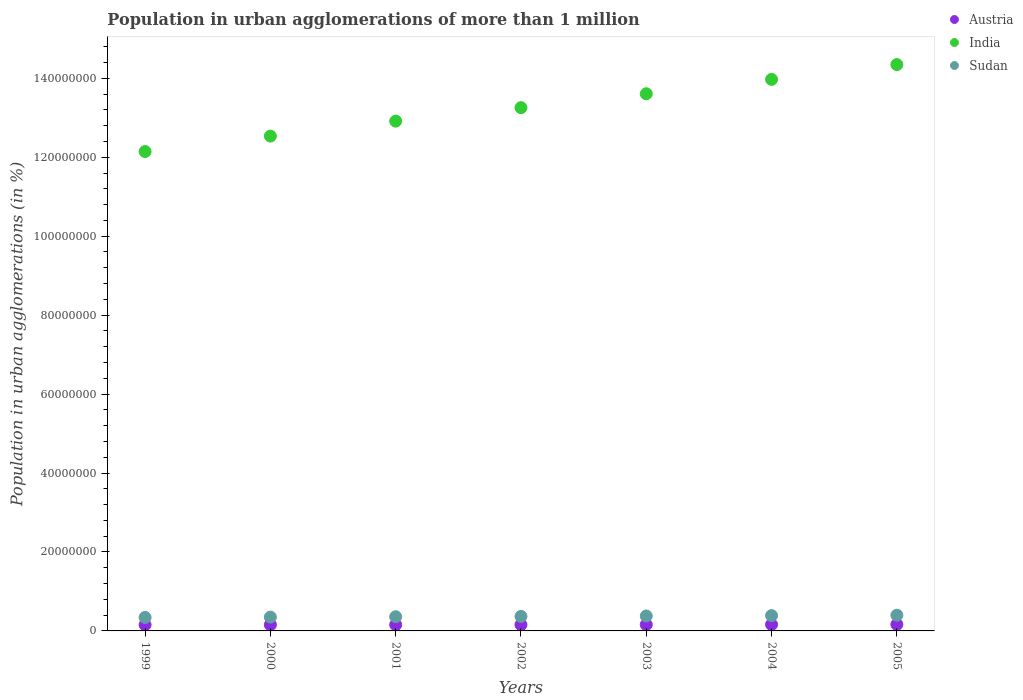Is the number of dotlines equal to the number of legend labels?
Give a very brief answer. Yes. What is the population in urban agglomerations in Sudan in 1999?
Offer a very short reply. 3.42e+06. Across all years, what is the maximum population in urban agglomerations in Austria?
Offer a very short reply. 1.64e+06. Across all years, what is the minimum population in urban agglomerations in Sudan?
Your response must be concise. 3.42e+06. In which year was the population in urban agglomerations in India minimum?
Keep it short and to the point. 1999. What is the total population in urban agglomerations in Sudan in the graph?
Keep it short and to the point. 2.58e+07. What is the difference between the population in urban agglomerations in India in 2001 and that in 2002?
Offer a very short reply. -3.41e+06. What is the difference between the population in urban agglomerations in India in 1999 and the population in urban agglomerations in Austria in 2005?
Your response must be concise. 1.20e+08. What is the average population in urban agglomerations in Sudan per year?
Your answer should be compact. 3.69e+06. In the year 1999, what is the difference between the population in urban agglomerations in India and population in urban agglomerations in Austria?
Your answer should be very brief. 1.20e+08. What is the ratio of the population in urban agglomerations in Austria in 2000 to that in 2004?
Keep it short and to the point. 0.96. Is the difference between the population in urban agglomerations in India in 2002 and 2005 greater than the difference between the population in urban agglomerations in Austria in 2002 and 2005?
Make the answer very short. No. What is the difference between the highest and the second highest population in urban agglomerations in Austria?
Offer a very short reply. 2.25e+04. What is the difference between the highest and the lowest population in urban agglomerations in Sudan?
Provide a short and direct response. 5.61e+05. In how many years, is the population in urban agglomerations in India greater than the average population in urban agglomerations in India taken over all years?
Your response must be concise. 4. Is the sum of the population in urban agglomerations in India in 1999 and 2002 greater than the maximum population in urban agglomerations in Sudan across all years?
Your answer should be compact. Yes. How many dotlines are there?
Give a very brief answer. 3. What is the difference between two consecutive major ticks on the Y-axis?
Keep it short and to the point. 2.00e+07. Does the graph contain grids?
Your answer should be compact. No. How many legend labels are there?
Make the answer very short. 3. What is the title of the graph?
Provide a short and direct response. Population in urban agglomerations of more than 1 million. Does "Euro area" appear as one of the legend labels in the graph?
Make the answer very short. No. What is the label or title of the X-axis?
Your answer should be very brief. Years. What is the label or title of the Y-axis?
Your answer should be compact. Population in urban agglomerations (in %). What is the Population in urban agglomerations (in %) in Austria in 1999?
Your answer should be very brief. 1.55e+06. What is the Population in urban agglomerations (in %) of India in 1999?
Offer a terse response. 1.21e+08. What is the Population in urban agglomerations (in %) in Sudan in 1999?
Your response must be concise. 3.42e+06. What is the Population in urban agglomerations (in %) of Austria in 2000?
Give a very brief answer. 1.55e+06. What is the Population in urban agglomerations (in %) of India in 2000?
Provide a succinct answer. 1.25e+08. What is the Population in urban agglomerations (in %) of Sudan in 2000?
Your response must be concise. 3.51e+06. What is the Population in urban agglomerations (in %) of Austria in 2001?
Make the answer very short. 1.55e+06. What is the Population in urban agglomerations (in %) of India in 2001?
Provide a succinct answer. 1.29e+08. What is the Population in urban agglomerations (in %) of Sudan in 2001?
Give a very brief answer. 3.60e+06. What is the Population in urban agglomerations (in %) in Austria in 2002?
Keep it short and to the point. 1.57e+06. What is the Population in urban agglomerations (in %) in India in 2002?
Your answer should be very brief. 1.33e+08. What is the Population in urban agglomerations (in %) in Sudan in 2002?
Offer a very short reply. 3.69e+06. What is the Population in urban agglomerations (in %) of Austria in 2003?
Your response must be concise. 1.60e+06. What is the Population in urban agglomerations (in %) in India in 2003?
Provide a short and direct response. 1.36e+08. What is the Population in urban agglomerations (in %) in Sudan in 2003?
Your response must be concise. 3.78e+06. What is the Population in urban agglomerations (in %) of Austria in 2004?
Give a very brief answer. 1.62e+06. What is the Population in urban agglomerations (in %) of India in 2004?
Make the answer very short. 1.40e+08. What is the Population in urban agglomerations (in %) of Sudan in 2004?
Your response must be concise. 3.88e+06. What is the Population in urban agglomerations (in %) in Austria in 2005?
Your answer should be very brief. 1.64e+06. What is the Population in urban agglomerations (in %) in India in 2005?
Ensure brevity in your answer.  1.43e+08. What is the Population in urban agglomerations (in %) in Sudan in 2005?
Offer a very short reply. 3.98e+06. Across all years, what is the maximum Population in urban agglomerations (in %) in Austria?
Ensure brevity in your answer.  1.64e+06. Across all years, what is the maximum Population in urban agglomerations (in %) in India?
Keep it short and to the point. 1.43e+08. Across all years, what is the maximum Population in urban agglomerations (in %) in Sudan?
Provide a succinct answer. 3.98e+06. Across all years, what is the minimum Population in urban agglomerations (in %) of Austria?
Provide a succinct answer. 1.55e+06. Across all years, what is the minimum Population in urban agglomerations (in %) in India?
Provide a succinct answer. 1.21e+08. Across all years, what is the minimum Population in urban agglomerations (in %) of Sudan?
Your response must be concise. 3.42e+06. What is the total Population in urban agglomerations (in %) of Austria in the graph?
Make the answer very short. 1.11e+07. What is the total Population in urban agglomerations (in %) of India in the graph?
Offer a very short reply. 9.28e+08. What is the total Population in urban agglomerations (in %) of Sudan in the graph?
Your response must be concise. 2.58e+07. What is the difference between the Population in urban agglomerations (in %) in Austria in 1999 and that in 2000?
Give a very brief answer. -1032. What is the difference between the Population in urban agglomerations (in %) of India in 1999 and that in 2000?
Ensure brevity in your answer.  -3.91e+06. What is the difference between the Population in urban agglomerations (in %) in Sudan in 1999 and that in 2000?
Offer a very short reply. -8.79e+04. What is the difference between the Population in urban agglomerations (in %) in Austria in 1999 and that in 2001?
Provide a short and direct response. -4685. What is the difference between the Population in urban agglomerations (in %) in India in 1999 and that in 2001?
Provide a succinct answer. -7.70e+06. What is the difference between the Population in urban agglomerations (in %) of Sudan in 1999 and that in 2001?
Offer a terse response. -1.78e+05. What is the difference between the Population in urban agglomerations (in %) in Austria in 1999 and that in 2002?
Make the answer very short. -2.63e+04. What is the difference between the Population in urban agglomerations (in %) in India in 1999 and that in 2002?
Keep it short and to the point. -1.11e+07. What is the difference between the Population in urban agglomerations (in %) of Sudan in 1999 and that in 2002?
Ensure brevity in your answer.  -2.70e+05. What is the difference between the Population in urban agglomerations (in %) of Austria in 1999 and that in 2003?
Offer a terse response. -4.81e+04. What is the difference between the Population in urban agglomerations (in %) of India in 1999 and that in 2003?
Give a very brief answer. -1.46e+07. What is the difference between the Population in urban agglomerations (in %) in Sudan in 1999 and that in 2003?
Your response must be concise. -3.65e+05. What is the difference between the Population in urban agglomerations (in %) in Austria in 1999 and that in 2004?
Keep it short and to the point. -7.03e+04. What is the difference between the Population in urban agglomerations (in %) in India in 1999 and that in 2004?
Your answer should be very brief. -1.83e+07. What is the difference between the Population in urban agglomerations (in %) of Sudan in 1999 and that in 2004?
Ensure brevity in your answer.  -4.62e+05. What is the difference between the Population in urban agglomerations (in %) in Austria in 1999 and that in 2005?
Ensure brevity in your answer.  -9.28e+04. What is the difference between the Population in urban agglomerations (in %) of India in 1999 and that in 2005?
Offer a very short reply. -2.20e+07. What is the difference between the Population in urban agglomerations (in %) of Sudan in 1999 and that in 2005?
Your response must be concise. -5.61e+05. What is the difference between the Population in urban agglomerations (in %) of Austria in 2000 and that in 2001?
Make the answer very short. -3653. What is the difference between the Population in urban agglomerations (in %) of India in 2000 and that in 2001?
Provide a short and direct response. -3.79e+06. What is the difference between the Population in urban agglomerations (in %) of Sudan in 2000 and that in 2001?
Make the answer very short. -8.99e+04. What is the difference between the Population in urban agglomerations (in %) of Austria in 2000 and that in 2002?
Your response must be concise. -2.52e+04. What is the difference between the Population in urban agglomerations (in %) in India in 2000 and that in 2002?
Offer a very short reply. -7.20e+06. What is the difference between the Population in urban agglomerations (in %) of Sudan in 2000 and that in 2002?
Give a very brief answer. -1.82e+05. What is the difference between the Population in urban agglomerations (in %) in Austria in 2000 and that in 2003?
Give a very brief answer. -4.71e+04. What is the difference between the Population in urban agglomerations (in %) in India in 2000 and that in 2003?
Ensure brevity in your answer.  -1.07e+07. What is the difference between the Population in urban agglomerations (in %) in Sudan in 2000 and that in 2003?
Keep it short and to the point. -2.77e+05. What is the difference between the Population in urban agglomerations (in %) of Austria in 2000 and that in 2004?
Provide a succinct answer. -6.93e+04. What is the difference between the Population in urban agglomerations (in %) of India in 2000 and that in 2004?
Your answer should be very brief. -1.44e+07. What is the difference between the Population in urban agglomerations (in %) in Sudan in 2000 and that in 2004?
Offer a terse response. -3.74e+05. What is the difference between the Population in urban agglomerations (in %) in Austria in 2000 and that in 2005?
Offer a terse response. -9.18e+04. What is the difference between the Population in urban agglomerations (in %) in India in 2000 and that in 2005?
Offer a very short reply. -1.81e+07. What is the difference between the Population in urban agglomerations (in %) of Sudan in 2000 and that in 2005?
Your answer should be very brief. -4.74e+05. What is the difference between the Population in urban agglomerations (in %) in Austria in 2001 and that in 2002?
Provide a succinct answer. -2.16e+04. What is the difference between the Population in urban agglomerations (in %) of India in 2001 and that in 2002?
Offer a very short reply. -3.41e+06. What is the difference between the Population in urban agglomerations (in %) of Sudan in 2001 and that in 2002?
Your answer should be very brief. -9.23e+04. What is the difference between the Population in urban agglomerations (in %) in Austria in 2001 and that in 2003?
Your answer should be compact. -4.34e+04. What is the difference between the Population in urban agglomerations (in %) in India in 2001 and that in 2003?
Give a very brief answer. -6.94e+06. What is the difference between the Population in urban agglomerations (in %) in Sudan in 2001 and that in 2003?
Your answer should be very brief. -1.87e+05. What is the difference between the Population in urban agglomerations (in %) of Austria in 2001 and that in 2004?
Your answer should be very brief. -6.57e+04. What is the difference between the Population in urban agglomerations (in %) in India in 2001 and that in 2004?
Your answer should be very brief. -1.06e+07. What is the difference between the Population in urban agglomerations (in %) of Sudan in 2001 and that in 2004?
Provide a short and direct response. -2.84e+05. What is the difference between the Population in urban agglomerations (in %) of Austria in 2001 and that in 2005?
Your response must be concise. -8.81e+04. What is the difference between the Population in urban agglomerations (in %) in India in 2001 and that in 2005?
Make the answer very short. -1.43e+07. What is the difference between the Population in urban agglomerations (in %) of Sudan in 2001 and that in 2005?
Offer a terse response. -3.84e+05. What is the difference between the Population in urban agglomerations (in %) in Austria in 2002 and that in 2003?
Provide a succinct answer. -2.19e+04. What is the difference between the Population in urban agglomerations (in %) in India in 2002 and that in 2003?
Your answer should be very brief. -3.52e+06. What is the difference between the Population in urban agglomerations (in %) in Sudan in 2002 and that in 2003?
Offer a terse response. -9.47e+04. What is the difference between the Population in urban agglomerations (in %) of Austria in 2002 and that in 2004?
Provide a succinct answer. -4.41e+04. What is the difference between the Population in urban agglomerations (in %) of India in 2002 and that in 2004?
Your response must be concise. -7.16e+06. What is the difference between the Population in urban agglomerations (in %) of Sudan in 2002 and that in 2004?
Provide a succinct answer. -1.92e+05. What is the difference between the Population in urban agglomerations (in %) of Austria in 2002 and that in 2005?
Offer a very short reply. -6.65e+04. What is the difference between the Population in urban agglomerations (in %) of India in 2002 and that in 2005?
Provide a succinct answer. -1.09e+07. What is the difference between the Population in urban agglomerations (in %) of Sudan in 2002 and that in 2005?
Offer a terse response. -2.91e+05. What is the difference between the Population in urban agglomerations (in %) in Austria in 2003 and that in 2004?
Keep it short and to the point. -2.22e+04. What is the difference between the Population in urban agglomerations (in %) of India in 2003 and that in 2004?
Keep it short and to the point. -3.64e+06. What is the difference between the Population in urban agglomerations (in %) in Sudan in 2003 and that in 2004?
Your response must be concise. -9.72e+04. What is the difference between the Population in urban agglomerations (in %) in Austria in 2003 and that in 2005?
Provide a short and direct response. -4.47e+04. What is the difference between the Population in urban agglomerations (in %) of India in 2003 and that in 2005?
Provide a short and direct response. -7.39e+06. What is the difference between the Population in urban agglomerations (in %) in Sudan in 2003 and that in 2005?
Offer a very short reply. -1.97e+05. What is the difference between the Population in urban agglomerations (in %) in Austria in 2004 and that in 2005?
Provide a short and direct response. -2.25e+04. What is the difference between the Population in urban agglomerations (in %) in India in 2004 and that in 2005?
Keep it short and to the point. -3.75e+06. What is the difference between the Population in urban agglomerations (in %) of Sudan in 2004 and that in 2005?
Your response must be concise. -9.95e+04. What is the difference between the Population in urban agglomerations (in %) of Austria in 1999 and the Population in urban agglomerations (in %) of India in 2000?
Ensure brevity in your answer.  -1.24e+08. What is the difference between the Population in urban agglomerations (in %) of Austria in 1999 and the Population in urban agglomerations (in %) of Sudan in 2000?
Give a very brief answer. -1.96e+06. What is the difference between the Population in urban agglomerations (in %) in India in 1999 and the Population in urban agglomerations (in %) in Sudan in 2000?
Provide a succinct answer. 1.18e+08. What is the difference between the Population in urban agglomerations (in %) in Austria in 1999 and the Population in urban agglomerations (in %) in India in 2001?
Ensure brevity in your answer.  -1.28e+08. What is the difference between the Population in urban agglomerations (in %) of Austria in 1999 and the Population in urban agglomerations (in %) of Sudan in 2001?
Keep it short and to the point. -2.05e+06. What is the difference between the Population in urban agglomerations (in %) of India in 1999 and the Population in urban agglomerations (in %) of Sudan in 2001?
Keep it short and to the point. 1.18e+08. What is the difference between the Population in urban agglomerations (in %) in Austria in 1999 and the Population in urban agglomerations (in %) in India in 2002?
Ensure brevity in your answer.  -1.31e+08. What is the difference between the Population in urban agglomerations (in %) of Austria in 1999 and the Population in urban agglomerations (in %) of Sudan in 2002?
Ensure brevity in your answer.  -2.14e+06. What is the difference between the Population in urban agglomerations (in %) in India in 1999 and the Population in urban agglomerations (in %) in Sudan in 2002?
Make the answer very short. 1.18e+08. What is the difference between the Population in urban agglomerations (in %) in Austria in 1999 and the Population in urban agglomerations (in %) in India in 2003?
Ensure brevity in your answer.  -1.35e+08. What is the difference between the Population in urban agglomerations (in %) of Austria in 1999 and the Population in urban agglomerations (in %) of Sudan in 2003?
Keep it short and to the point. -2.23e+06. What is the difference between the Population in urban agglomerations (in %) of India in 1999 and the Population in urban agglomerations (in %) of Sudan in 2003?
Your response must be concise. 1.18e+08. What is the difference between the Population in urban agglomerations (in %) of Austria in 1999 and the Population in urban agglomerations (in %) of India in 2004?
Keep it short and to the point. -1.38e+08. What is the difference between the Population in urban agglomerations (in %) in Austria in 1999 and the Population in urban agglomerations (in %) in Sudan in 2004?
Make the answer very short. -2.33e+06. What is the difference between the Population in urban agglomerations (in %) in India in 1999 and the Population in urban agglomerations (in %) in Sudan in 2004?
Your answer should be compact. 1.18e+08. What is the difference between the Population in urban agglomerations (in %) of Austria in 1999 and the Population in urban agglomerations (in %) of India in 2005?
Offer a terse response. -1.42e+08. What is the difference between the Population in urban agglomerations (in %) of Austria in 1999 and the Population in urban agglomerations (in %) of Sudan in 2005?
Offer a very short reply. -2.43e+06. What is the difference between the Population in urban agglomerations (in %) of India in 1999 and the Population in urban agglomerations (in %) of Sudan in 2005?
Make the answer very short. 1.17e+08. What is the difference between the Population in urban agglomerations (in %) in Austria in 2000 and the Population in urban agglomerations (in %) in India in 2001?
Your response must be concise. -1.28e+08. What is the difference between the Population in urban agglomerations (in %) of Austria in 2000 and the Population in urban agglomerations (in %) of Sudan in 2001?
Your response must be concise. -2.05e+06. What is the difference between the Population in urban agglomerations (in %) in India in 2000 and the Population in urban agglomerations (in %) in Sudan in 2001?
Ensure brevity in your answer.  1.22e+08. What is the difference between the Population in urban agglomerations (in %) of Austria in 2000 and the Population in urban agglomerations (in %) of India in 2002?
Offer a very short reply. -1.31e+08. What is the difference between the Population in urban agglomerations (in %) of Austria in 2000 and the Population in urban agglomerations (in %) of Sudan in 2002?
Your answer should be compact. -2.14e+06. What is the difference between the Population in urban agglomerations (in %) of India in 2000 and the Population in urban agglomerations (in %) of Sudan in 2002?
Offer a terse response. 1.22e+08. What is the difference between the Population in urban agglomerations (in %) of Austria in 2000 and the Population in urban agglomerations (in %) of India in 2003?
Your answer should be very brief. -1.35e+08. What is the difference between the Population in urban agglomerations (in %) of Austria in 2000 and the Population in urban agglomerations (in %) of Sudan in 2003?
Provide a succinct answer. -2.23e+06. What is the difference between the Population in urban agglomerations (in %) of India in 2000 and the Population in urban agglomerations (in %) of Sudan in 2003?
Ensure brevity in your answer.  1.22e+08. What is the difference between the Population in urban agglomerations (in %) of Austria in 2000 and the Population in urban agglomerations (in %) of India in 2004?
Keep it short and to the point. -1.38e+08. What is the difference between the Population in urban agglomerations (in %) of Austria in 2000 and the Population in urban agglomerations (in %) of Sudan in 2004?
Offer a very short reply. -2.33e+06. What is the difference between the Population in urban agglomerations (in %) in India in 2000 and the Population in urban agglomerations (in %) in Sudan in 2004?
Provide a succinct answer. 1.21e+08. What is the difference between the Population in urban agglomerations (in %) of Austria in 2000 and the Population in urban agglomerations (in %) of India in 2005?
Offer a terse response. -1.42e+08. What is the difference between the Population in urban agglomerations (in %) of Austria in 2000 and the Population in urban agglomerations (in %) of Sudan in 2005?
Provide a short and direct response. -2.43e+06. What is the difference between the Population in urban agglomerations (in %) in India in 2000 and the Population in urban agglomerations (in %) in Sudan in 2005?
Your answer should be compact. 1.21e+08. What is the difference between the Population in urban agglomerations (in %) in Austria in 2001 and the Population in urban agglomerations (in %) in India in 2002?
Your response must be concise. -1.31e+08. What is the difference between the Population in urban agglomerations (in %) in Austria in 2001 and the Population in urban agglomerations (in %) in Sudan in 2002?
Your answer should be very brief. -2.13e+06. What is the difference between the Population in urban agglomerations (in %) in India in 2001 and the Population in urban agglomerations (in %) in Sudan in 2002?
Your answer should be compact. 1.25e+08. What is the difference between the Population in urban agglomerations (in %) in Austria in 2001 and the Population in urban agglomerations (in %) in India in 2003?
Make the answer very short. -1.35e+08. What is the difference between the Population in urban agglomerations (in %) of Austria in 2001 and the Population in urban agglomerations (in %) of Sudan in 2003?
Your answer should be compact. -2.23e+06. What is the difference between the Population in urban agglomerations (in %) in India in 2001 and the Population in urban agglomerations (in %) in Sudan in 2003?
Offer a very short reply. 1.25e+08. What is the difference between the Population in urban agglomerations (in %) in Austria in 2001 and the Population in urban agglomerations (in %) in India in 2004?
Make the answer very short. -1.38e+08. What is the difference between the Population in urban agglomerations (in %) of Austria in 2001 and the Population in urban agglomerations (in %) of Sudan in 2004?
Give a very brief answer. -2.33e+06. What is the difference between the Population in urban agglomerations (in %) of India in 2001 and the Population in urban agglomerations (in %) of Sudan in 2004?
Offer a very short reply. 1.25e+08. What is the difference between the Population in urban agglomerations (in %) of Austria in 2001 and the Population in urban agglomerations (in %) of India in 2005?
Keep it short and to the point. -1.42e+08. What is the difference between the Population in urban agglomerations (in %) of Austria in 2001 and the Population in urban agglomerations (in %) of Sudan in 2005?
Keep it short and to the point. -2.43e+06. What is the difference between the Population in urban agglomerations (in %) in India in 2001 and the Population in urban agglomerations (in %) in Sudan in 2005?
Provide a succinct answer. 1.25e+08. What is the difference between the Population in urban agglomerations (in %) of Austria in 2002 and the Population in urban agglomerations (in %) of India in 2003?
Your response must be concise. -1.35e+08. What is the difference between the Population in urban agglomerations (in %) of Austria in 2002 and the Population in urban agglomerations (in %) of Sudan in 2003?
Your response must be concise. -2.21e+06. What is the difference between the Population in urban agglomerations (in %) in India in 2002 and the Population in urban agglomerations (in %) in Sudan in 2003?
Make the answer very short. 1.29e+08. What is the difference between the Population in urban agglomerations (in %) of Austria in 2002 and the Population in urban agglomerations (in %) of India in 2004?
Provide a short and direct response. -1.38e+08. What is the difference between the Population in urban agglomerations (in %) of Austria in 2002 and the Population in urban agglomerations (in %) of Sudan in 2004?
Give a very brief answer. -2.31e+06. What is the difference between the Population in urban agglomerations (in %) of India in 2002 and the Population in urban agglomerations (in %) of Sudan in 2004?
Offer a very short reply. 1.29e+08. What is the difference between the Population in urban agglomerations (in %) of Austria in 2002 and the Population in urban agglomerations (in %) of India in 2005?
Your answer should be compact. -1.42e+08. What is the difference between the Population in urban agglomerations (in %) of Austria in 2002 and the Population in urban agglomerations (in %) of Sudan in 2005?
Ensure brevity in your answer.  -2.40e+06. What is the difference between the Population in urban agglomerations (in %) of India in 2002 and the Population in urban agglomerations (in %) of Sudan in 2005?
Your response must be concise. 1.29e+08. What is the difference between the Population in urban agglomerations (in %) in Austria in 2003 and the Population in urban agglomerations (in %) in India in 2004?
Give a very brief answer. -1.38e+08. What is the difference between the Population in urban agglomerations (in %) of Austria in 2003 and the Population in urban agglomerations (in %) of Sudan in 2004?
Ensure brevity in your answer.  -2.28e+06. What is the difference between the Population in urban agglomerations (in %) of India in 2003 and the Population in urban agglomerations (in %) of Sudan in 2004?
Give a very brief answer. 1.32e+08. What is the difference between the Population in urban agglomerations (in %) in Austria in 2003 and the Population in urban agglomerations (in %) in India in 2005?
Provide a succinct answer. -1.42e+08. What is the difference between the Population in urban agglomerations (in %) of Austria in 2003 and the Population in urban agglomerations (in %) of Sudan in 2005?
Offer a very short reply. -2.38e+06. What is the difference between the Population in urban agglomerations (in %) in India in 2003 and the Population in urban agglomerations (in %) in Sudan in 2005?
Provide a short and direct response. 1.32e+08. What is the difference between the Population in urban agglomerations (in %) of Austria in 2004 and the Population in urban agglomerations (in %) of India in 2005?
Make the answer very short. -1.42e+08. What is the difference between the Population in urban agglomerations (in %) in Austria in 2004 and the Population in urban agglomerations (in %) in Sudan in 2005?
Your response must be concise. -2.36e+06. What is the difference between the Population in urban agglomerations (in %) in India in 2004 and the Population in urban agglomerations (in %) in Sudan in 2005?
Offer a very short reply. 1.36e+08. What is the average Population in urban agglomerations (in %) in Austria per year?
Offer a very short reply. 1.58e+06. What is the average Population in urban agglomerations (in %) in India per year?
Provide a succinct answer. 1.33e+08. What is the average Population in urban agglomerations (in %) of Sudan per year?
Keep it short and to the point. 3.69e+06. In the year 1999, what is the difference between the Population in urban agglomerations (in %) in Austria and Population in urban agglomerations (in %) in India?
Give a very brief answer. -1.20e+08. In the year 1999, what is the difference between the Population in urban agglomerations (in %) in Austria and Population in urban agglomerations (in %) in Sudan?
Keep it short and to the point. -1.87e+06. In the year 1999, what is the difference between the Population in urban agglomerations (in %) of India and Population in urban agglomerations (in %) of Sudan?
Offer a terse response. 1.18e+08. In the year 2000, what is the difference between the Population in urban agglomerations (in %) of Austria and Population in urban agglomerations (in %) of India?
Your answer should be compact. -1.24e+08. In the year 2000, what is the difference between the Population in urban agglomerations (in %) in Austria and Population in urban agglomerations (in %) in Sudan?
Your answer should be compact. -1.96e+06. In the year 2000, what is the difference between the Population in urban agglomerations (in %) of India and Population in urban agglomerations (in %) of Sudan?
Offer a terse response. 1.22e+08. In the year 2001, what is the difference between the Population in urban agglomerations (in %) in Austria and Population in urban agglomerations (in %) in India?
Give a very brief answer. -1.28e+08. In the year 2001, what is the difference between the Population in urban agglomerations (in %) of Austria and Population in urban agglomerations (in %) of Sudan?
Your response must be concise. -2.04e+06. In the year 2001, what is the difference between the Population in urban agglomerations (in %) in India and Population in urban agglomerations (in %) in Sudan?
Your answer should be compact. 1.26e+08. In the year 2002, what is the difference between the Population in urban agglomerations (in %) in Austria and Population in urban agglomerations (in %) in India?
Make the answer very short. -1.31e+08. In the year 2002, what is the difference between the Population in urban agglomerations (in %) in Austria and Population in urban agglomerations (in %) in Sudan?
Give a very brief answer. -2.11e+06. In the year 2002, what is the difference between the Population in urban agglomerations (in %) of India and Population in urban agglomerations (in %) of Sudan?
Your answer should be very brief. 1.29e+08. In the year 2003, what is the difference between the Population in urban agglomerations (in %) of Austria and Population in urban agglomerations (in %) of India?
Provide a succinct answer. -1.34e+08. In the year 2003, what is the difference between the Population in urban agglomerations (in %) of Austria and Population in urban agglomerations (in %) of Sudan?
Your answer should be compact. -2.19e+06. In the year 2003, what is the difference between the Population in urban agglomerations (in %) of India and Population in urban agglomerations (in %) of Sudan?
Your answer should be very brief. 1.32e+08. In the year 2004, what is the difference between the Population in urban agglomerations (in %) of Austria and Population in urban agglomerations (in %) of India?
Provide a succinct answer. -1.38e+08. In the year 2004, what is the difference between the Population in urban agglomerations (in %) in Austria and Population in urban agglomerations (in %) in Sudan?
Give a very brief answer. -2.26e+06. In the year 2004, what is the difference between the Population in urban agglomerations (in %) of India and Population in urban agglomerations (in %) of Sudan?
Give a very brief answer. 1.36e+08. In the year 2005, what is the difference between the Population in urban agglomerations (in %) of Austria and Population in urban agglomerations (in %) of India?
Keep it short and to the point. -1.42e+08. In the year 2005, what is the difference between the Population in urban agglomerations (in %) in Austria and Population in urban agglomerations (in %) in Sudan?
Your response must be concise. -2.34e+06. In the year 2005, what is the difference between the Population in urban agglomerations (in %) in India and Population in urban agglomerations (in %) in Sudan?
Give a very brief answer. 1.39e+08. What is the ratio of the Population in urban agglomerations (in %) in Austria in 1999 to that in 2000?
Keep it short and to the point. 1. What is the ratio of the Population in urban agglomerations (in %) in India in 1999 to that in 2000?
Make the answer very short. 0.97. What is the ratio of the Population in urban agglomerations (in %) in Sudan in 1999 to that in 2000?
Keep it short and to the point. 0.97. What is the ratio of the Population in urban agglomerations (in %) in India in 1999 to that in 2001?
Your response must be concise. 0.94. What is the ratio of the Population in urban agglomerations (in %) in Sudan in 1999 to that in 2001?
Keep it short and to the point. 0.95. What is the ratio of the Population in urban agglomerations (in %) of Austria in 1999 to that in 2002?
Offer a terse response. 0.98. What is the ratio of the Population in urban agglomerations (in %) of India in 1999 to that in 2002?
Provide a short and direct response. 0.92. What is the ratio of the Population in urban agglomerations (in %) in Sudan in 1999 to that in 2002?
Your answer should be very brief. 0.93. What is the ratio of the Population in urban agglomerations (in %) in Austria in 1999 to that in 2003?
Your response must be concise. 0.97. What is the ratio of the Population in urban agglomerations (in %) of India in 1999 to that in 2003?
Your answer should be very brief. 0.89. What is the ratio of the Population in urban agglomerations (in %) in Sudan in 1999 to that in 2003?
Offer a very short reply. 0.9. What is the ratio of the Population in urban agglomerations (in %) in Austria in 1999 to that in 2004?
Provide a short and direct response. 0.96. What is the ratio of the Population in urban agglomerations (in %) of India in 1999 to that in 2004?
Your answer should be very brief. 0.87. What is the ratio of the Population in urban agglomerations (in %) in Sudan in 1999 to that in 2004?
Your response must be concise. 0.88. What is the ratio of the Population in urban agglomerations (in %) of Austria in 1999 to that in 2005?
Offer a terse response. 0.94. What is the ratio of the Population in urban agglomerations (in %) of India in 1999 to that in 2005?
Offer a very short reply. 0.85. What is the ratio of the Population in urban agglomerations (in %) of Sudan in 1999 to that in 2005?
Provide a short and direct response. 0.86. What is the ratio of the Population in urban agglomerations (in %) of Austria in 2000 to that in 2001?
Offer a very short reply. 1. What is the ratio of the Population in urban agglomerations (in %) in India in 2000 to that in 2001?
Your answer should be compact. 0.97. What is the ratio of the Population in urban agglomerations (in %) in Sudan in 2000 to that in 2001?
Keep it short and to the point. 0.97. What is the ratio of the Population in urban agglomerations (in %) in India in 2000 to that in 2002?
Your answer should be very brief. 0.95. What is the ratio of the Population in urban agglomerations (in %) in Sudan in 2000 to that in 2002?
Your answer should be compact. 0.95. What is the ratio of the Population in urban agglomerations (in %) of Austria in 2000 to that in 2003?
Provide a succinct answer. 0.97. What is the ratio of the Population in urban agglomerations (in %) in India in 2000 to that in 2003?
Offer a very short reply. 0.92. What is the ratio of the Population in urban agglomerations (in %) of Sudan in 2000 to that in 2003?
Give a very brief answer. 0.93. What is the ratio of the Population in urban agglomerations (in %) of Austria in 2000 to that in 2004?
Provide a short and direct response. 0.96. What is the ratio of the Population in urban agglomerations (in %) of India in 2000 to that in 2004?
Provide a short and direct response. 0.9. What is the ratio of the Population in urban agglomerations (in %) of Sudan in 2000 to that in 2004?
Your response must be concise. 0.9. What is the ratio of the Population in urban agglomerations (in %) of Austria in 2000 to that in 2005?
Give a very brief answer. 0.94. What is the ratio of the Population in urban agglomerations (in %) of India in 2000 to that in 2005?
Your answer should be compact. 0.87. What is the ratio of the Population in urban agglomerations (in %) of Sudan in 2000 to that in 2005?
Your answer should be compact. 0.88. What is the ratio of the Population in urban agglomerations (in %) in Austria in 2001 to that in 2002?
Provide a succinct answer. 0.99. What is the ratio of the Population in urban agglomerations (in %) of India in 2001 to that in 2002?
Keep it short and to the point. 0.97. What is the ratio of the Population in urban agglomerations (in %) of Austria in 2001 to that in 2003?
Ensure brevity in your answer.  0.97. What is the ratio of the Population in urban agglomerations (in %) of India in 2001 to that in 2003?
Ensure brevity in your answer.  0.95. What is the ratio of the Population in urban agglomerations (in %) in Sudan in 2001 to that in 2003?
Provide a succinct answer. 0.95. What is the ratio of the Population in urban agglomerations (in %) of Austria in 2001 to that in 2004?
Your answer should be compact. 0.96. What is the ratio of the Population in urban agglomerations (in %) of India in 2001 to that in 2004?
Keep it short and to the point. 0.92. What is the ratio of the Population in urban agglomerations (in %) of Sudan in 2001 to that in 2004?
Your answer should be very brief. 0.93. What is the ratio of the Population in urban agglomerations (in %) in Austria in 2001 to that in 2005?
Your answer should be compact. 0.95. What is the ratio of the Population in urban agglomerations (in %) in India in 2001 to that in 2005?
Your response must be concise. 0.9. What is the ratio of the Population in urban agglomerations (in %) in Sudan in 2001 to that in 2005?
Provide a short and direct response. 0.9. What is the ratio of the Population in urban agglomerations (in %) of Austria in 2002 to that in 2003?
Provide a short and direct response. 0.99. What is the ratio of the Population in urban agglomerations (in %) in India in 2002 to that in 2003?
Ensure brevity in your answer.  0.97. What is the ratio of the Population in urban agglomerations (in %) of Austria in 2002 to that in 2004?
Keep it short and to the point. 0.97. What is the ratio of the Population in urban agglomerations (in %) in India in 2002 to that in 2004?
Your answer should be compact. 0.95. What is the ratio of the Population in urban agglomerations (in %) of Sudan in 2002 to that in 2004?
Your answer should be compact. 0.95. What is the ratio of the Population in urban agglomerations (in %) of Austria in 2002 to that in 2005?
Your response must be concise. 0.96. What is the ratio of the Population in urban agglomerations (in %) of India in 2002 to that in 2005?
Offer a terse response. 0.92. What is the ratio of the Population in urban agglomerations (in %) of Sudan in 2002 to that in 2005?
Offer a very short reply. 0.93. What is the ratio of the Population in urban agglomerations (in %) in Austria in 2003 to that in 2004?
Offer a terse response. 0.99. What is the ratio of the Population in urban agglomerations (in %) of India in 2003 to that in 2004?
Make the answer very short. 0.97. What is the ratio of the Population in urban agglomerations (in %) in Sudan in 2003 to that in 2004?
Your answer should be compact. 0.97. What is the ratio of the Population in urban agglomerations (in %) in Austria in 2003 to that in 2005?
Provide a succinct answer. 0.97. What is the ratio of the Population in urban agglomerations (in %) of India in 2003 to that in 2005?
Provide a succinct answer. 0.95. What is the ratio of the Population in urban agglomerations (in %) in Sudan in 2003 to that in 2005?
Provide a short and direct response. 0.95. What is the ratio of the Population in urban agglomerations (in %) of Austria in 2004 to that in 2005?
Your response must be concise. 0.99. What is the ratio of the Population in urban agglomerations (in %) in India in 2004 to that in 2005?
Give a very brief answer. 0.97. What is the ratio of the Population in urban agglomerations (in %) of Sudan in 2004 to that in 2005?
Give a very brief answer. 0.97. What is the difference between the highest and the second highest Population in urban agglomerations (in %) in Austria?
Give a very brief answer. 2.25e+04. What is the difference between the highest and the second highest Population in urban agglomerations (in %) of India?
Offer a very short reply. 3.75e+06. What is the difference between the highest and the second highest Population in urban agglomerations (in %) of Sudan?
Your answer should be compact. 9.95e+04. What is the difference between the highest and the lowest Population in urban agglomerations (in %) in Austria?
Provide a succinct answer. 9.28e+04. What is the difference between the highest and the lowest Population in urban agglomerations (in %) in India?
Your response must be concise. 2.20e+07. What is the difference between the highest and the lowest Population in urban agglomerations (in %) in Sudan?
Offer a terse response. 5.61e+05. 